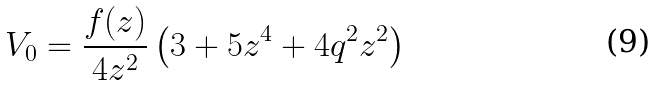<formula> <loc_0><loc_0><loc_500><loc_500>V _ { 0 } = \frac { f ( z ) } { 4 z ^ { 2 } } \left ( 3 + 5 z ^ { 4 } + 4 q ^ { 2 } z ^ { 2 } \right )</formula> 